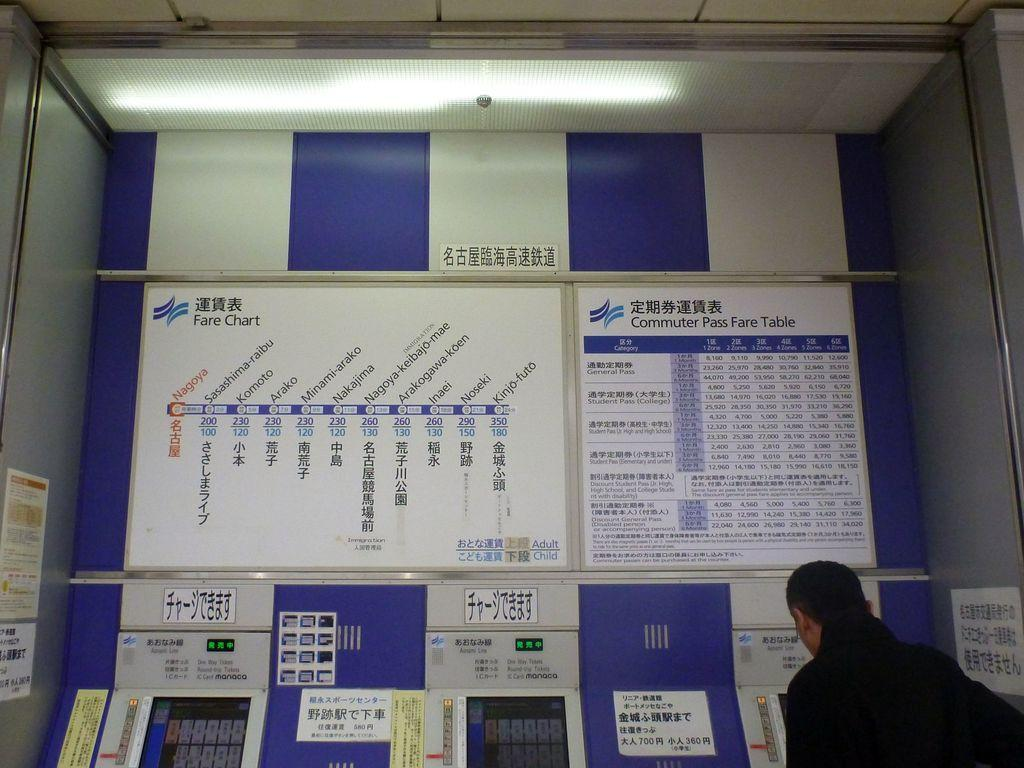<image>
Give a short and clear explanation of the subsequent image. a wall that has a poster on it that says 'commuter pass fare table' on it 